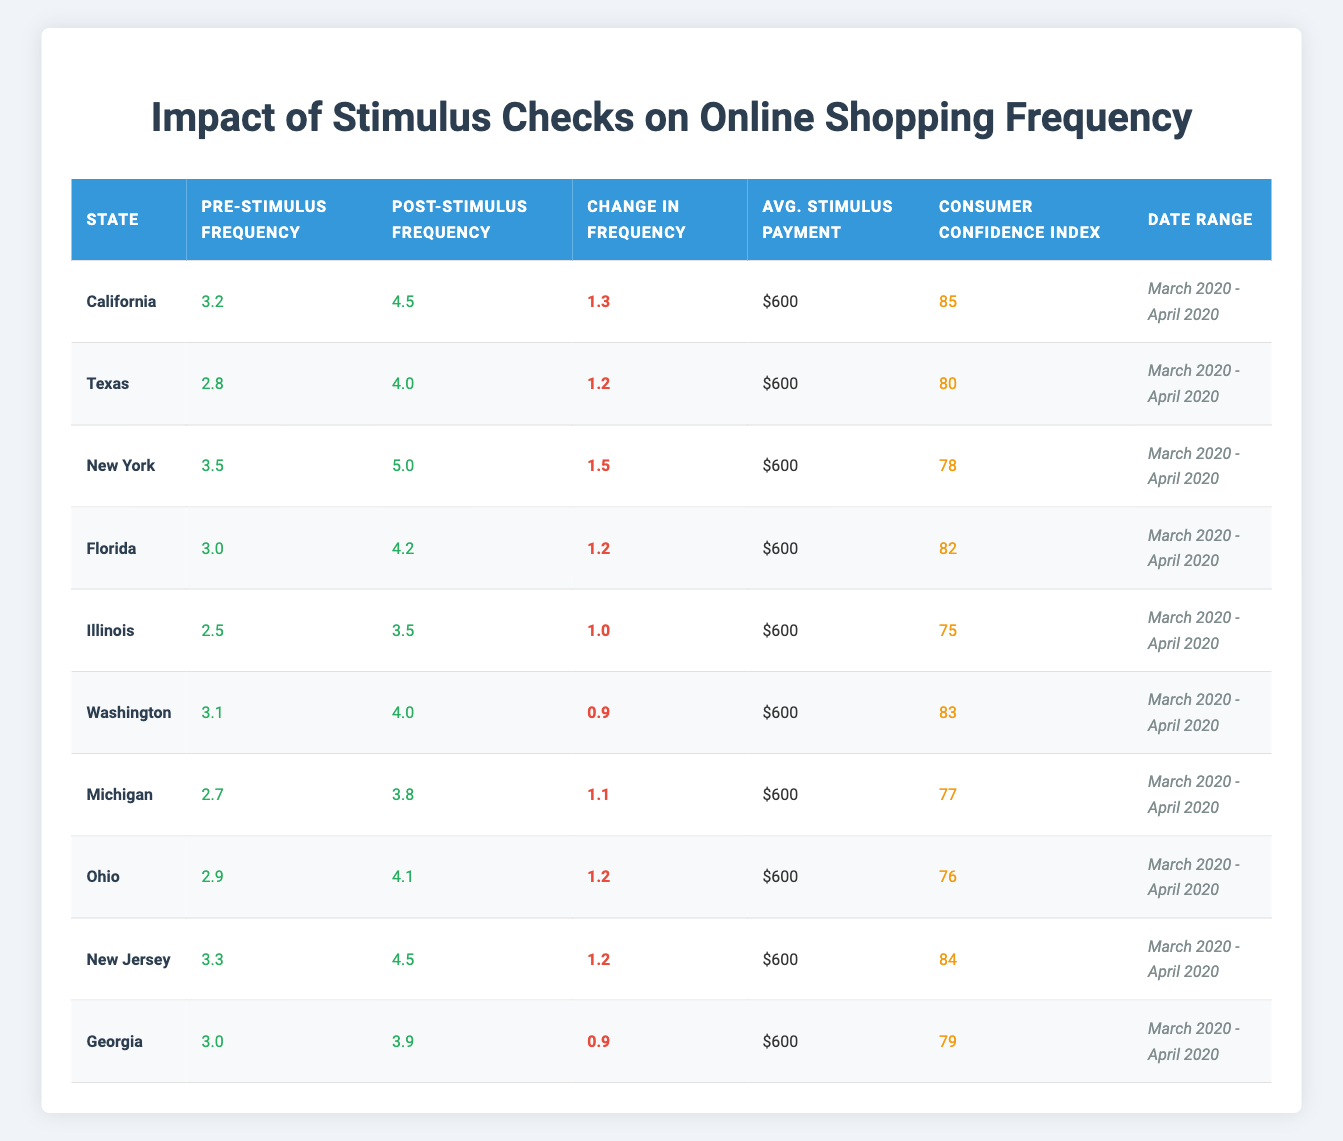What is the change in online shopping frequency for New York? The pre-stimulus frequency in New York is 3.5 and the post-stimulus frequency is 5.0. To find the change in frequency, subtract the pre-stimulus frequency from the post-stimulus frequency: 5.0 - 3.5 = 1.5.
Answer: 1.5 Which state had the highest consumer confidence index? By looking at the consumer confidence indices, California has a score of 85, which is the highest compared to the other states listed.
Answer: California What is the average online shopping frequency before stimulus payments across all states? To find the average pre-stimulus frequency, sum all pre-stimulus values: 3.2 + 2.8 + 3.5 + 3.0 + 2.5 + 3.1 + 2.7 + 2.9 + 3.3 + 3.0 = 30.0. There are 10 states, so the average is 30.0 / 10 = 3.0.
Answer: 3.0 Did the online shopping frequency increase in all states after the stimulus payments? If we compare the pre-stimulus and post-stimulus frequencies for each state, we see that all post-stimulus values are greater than their respective pre-stimulus values. Therefore, the online shopping frequency did indeed increase in all states after the stimulus payments.
Answer: Yes What is the difference in online shopping frequency increases between California and Georgia? California's increase is 1.3 while Georgia's increase is 0.9. To find the difference, subtract Georgia's increase from California's: 1.3 - 0.9 = 0.4.
Answer: 0.4 Which state experienced the lowest increase in online shopping frequency? By evaluating the change in frequency for each state, we see that both Washington and Georgia had the lowest increase of 0.9. However, Washington's overall frequency is higher post-stimulus. Therefore, Georgia is the one to note for the lowest increase relative to its own values.
Answer: Georgia Is the average stimulus payment consistent across all states? According to the table, the average stimulus payment for all states is $600, and there's no variation indicated in the data. Thus, it is consistent.
Answer: Yes What is the median change in online shopping frequency among the states? To find the median, we first arrange the changes in increasing order: 0.9, 0.9, 1.0, 1.1, 1.2, 1.2, 1.2, 1.3, 1.5. There are 10 values, so the median will be the average of the 5th and 6th values: (1.2 + 1.2) / 2 = 1.2.
Answer: 1.2 